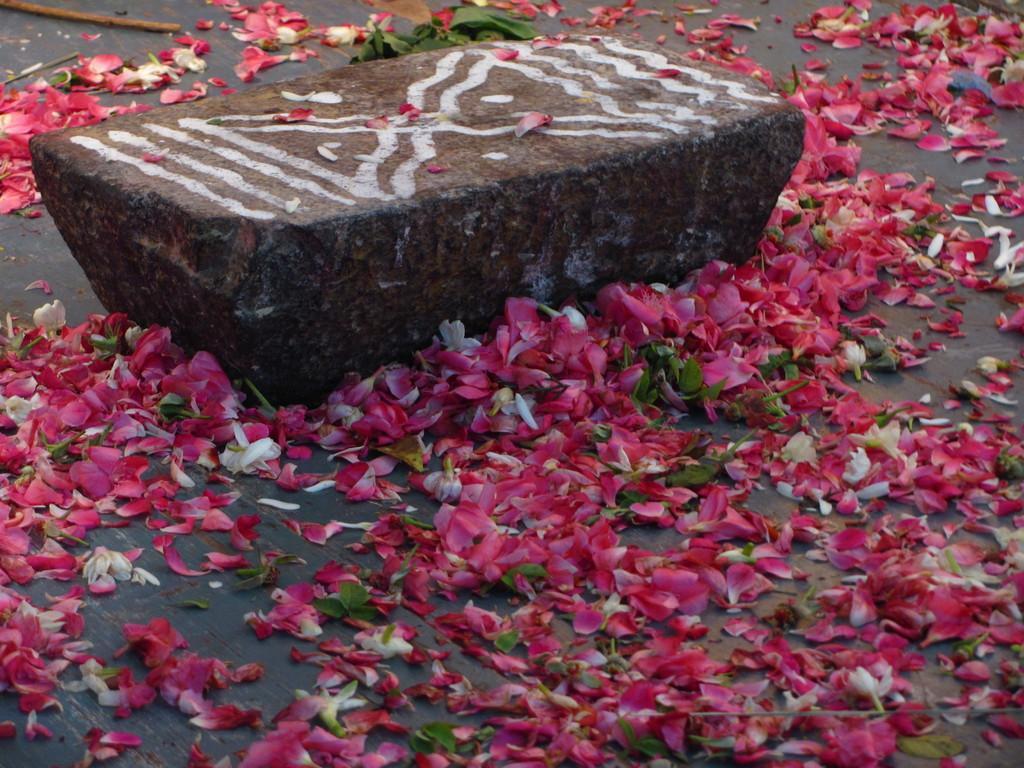Describe this image in one or two sentences. In this picture I can see a stone with paintings on it, and there are flower petals and leaves on the floor. 